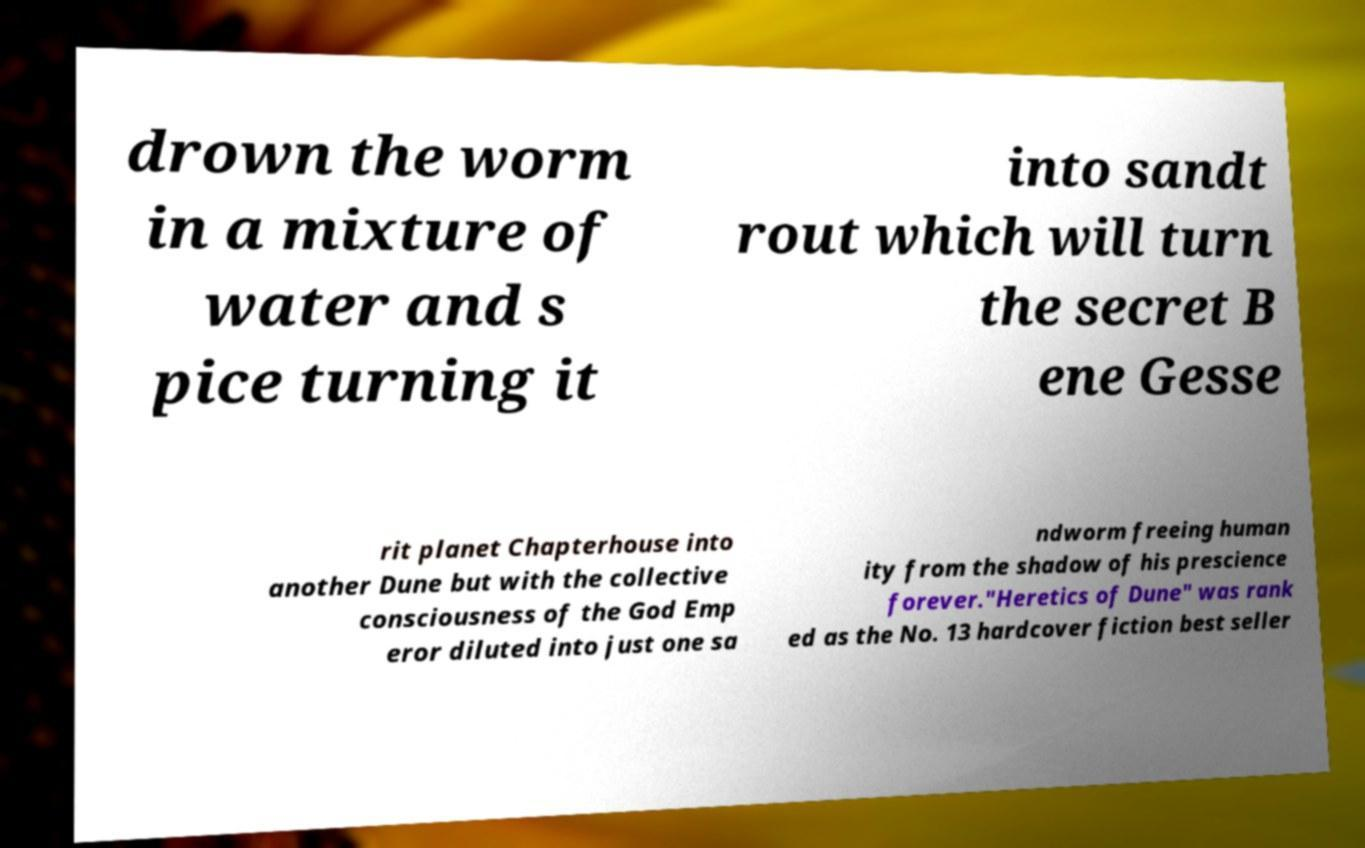Could you extract and type out the text from this image? drown the worm in a mixture of water and s pice turning it into sandt rout which will turn the secret B ene Gesse rit planet Chapterhouse into another Dune but with the collective consciousness of the God Emp eror diluted into just one sa ndworm freeing human ity from the shadow of his prescience forever."Heretics of Dune" was rank ed as the No. 13 hardcover fiction best seller 